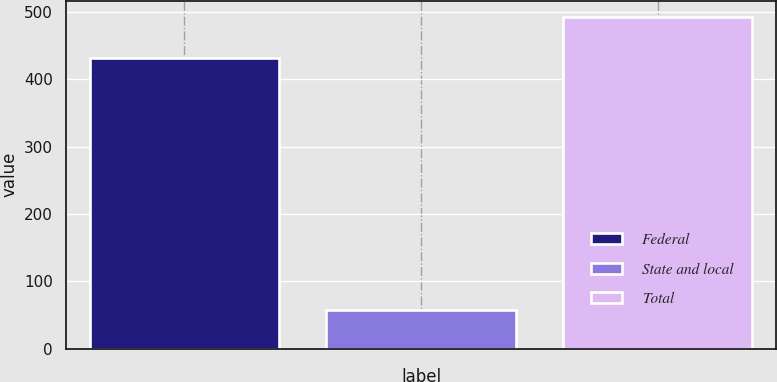Convert chart. <chart><loc_0><loc_0><loc_500><loc_500><bar_chart><fcel>Federal<fcel>State and local<fcel>Total<nl><fcel>432<fcel>57<fcel>492<nl></chart> 